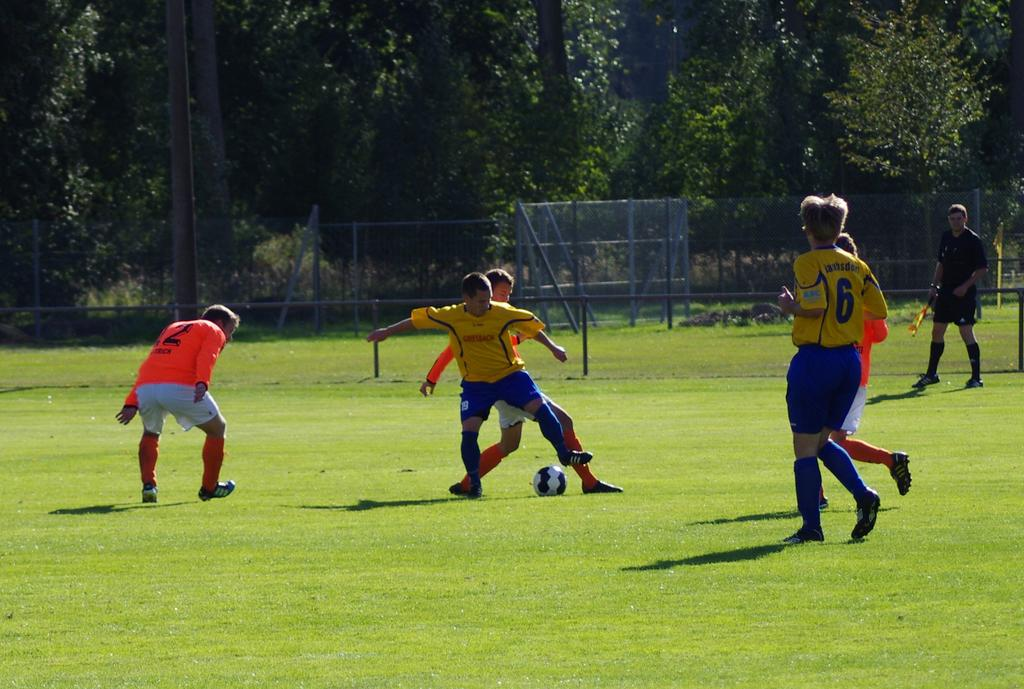<image>
Offer a succinct explanation of the picture presented. Number 6 watches his teammate battle another player for the soccer ball. 